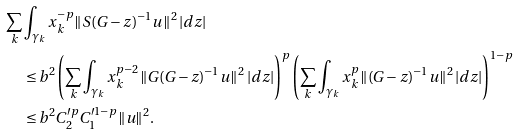Convert formula to latex. <formula><loc_0><loc_0><loc_500><loc_500>\sum _ { k } & \int _ { \gamma _ { k } } x _ { k } ^ { - p } \| S ( G - z ) ^ { - 1 } u \| ^ { 2 } \, | d z | \\ & \leq b ^ { 2 } \left ( \sum _ { k } \int _ { \gamma _ { k } } x _ { k } ^ { p - 2 } \| G ( G - z ) ^ { - 1 } u \| ^ { 2 } \, | d z | \right ) ^ { p } \left ( \sum _ { k } \int _ { \gamma _ { k } } x _ { k } ^ { p } \| ( G - z ) ^ { - 1 } u \| ^ { 2 } \, | d z | \right ) ^ { 1 - p } \\ & \leq b ^ { 2 } C _ { 2 } ^ { \prime p } C _ { 1 } ^ { \prime 1 - p } \| u \| ^ { 2 } .</formula> 